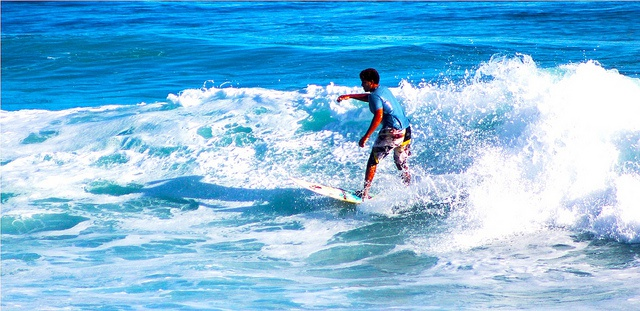Describe the objects in this image and their specific colors. I can see people in darkgray, black, lightgray, navy, and lightblue tones and surfboard in darkgray, white, lightblue, and pink tones in this image. 